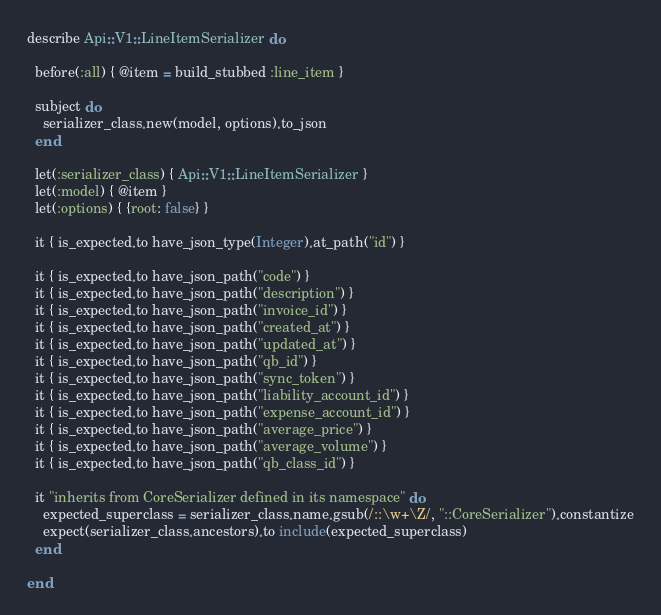<code> <loc_0><loc_0><loc_500><loc_500><_Ruby_>describe Api::V1::LineItemSerializer do

  before(:all) { @item = build_stubbed :line_item }

  subject do
    serializer_class.new(model, options).to_json
  end

  let(:serializer_class) { Api::V1::LineItemSerializer }
  let(:model) { @item }
  let(:options) { {root: false} }

  it { is_expected.to have_json_type(Integer).at_path("id") }

  it { is_expected.to have_json_path("code") }
  it { is_expected.to have_json_path("description") }
  it { is_expected.to have_json_path("invoice_id") }
  it { is_expected.to have_json_path("created_at") }
  it { is_expected.to have_json_path("updated_at") }
  it { is_expected.to have_json_path("qb_id") }
  it { is_expected.to have_json_path("sync_token") }
  it { is_expected.to have_json_path("liability_account_id") }
  it { is_expected.to have_json_path("expense_account_id") }
  it { is_expected.to have_json_path("average_price") }
  it { is_expected.to have_json_path("average_volume") }
  it { is_expected.to have_json_path("qb_class_id") }

  it "inherits from CoreSerializer defined in its namespace" do
    expected_superclass = serializer_class.name.gsub(/::\w+\Z/, "::CoreSerializer").constantize
    expect(serializer_class.ancestors).to include(expected_superclass)
  end

end
</code> 